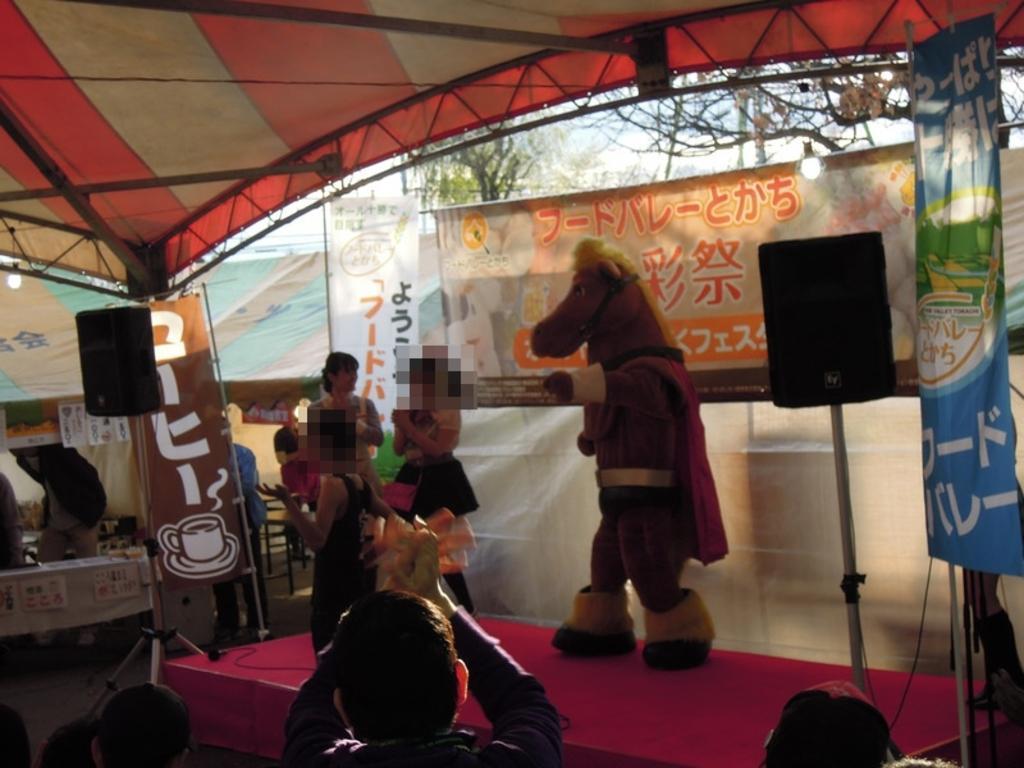How would you summarize this image in a sentence or two? This picture describes about group of people, they are all under the tent, on the left side of the image we can see a speaker, and we can find another speaker on the right side of the image, in the background we can find few hoardings and trees. 